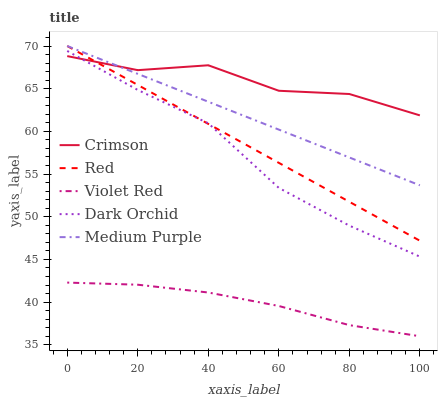Does Medium Purple have the minimum area under the curve?
Answer yes or no. No. Does Medium Purple have the maximum area under the curve?
Answer yes or no. No. Is Medium Purple the smoothest?
Answer yes or no. No. Is Medium Purple the roughest?
Answer yes or no. No. Does Medium Purple have the lowest value?
Answer yes or no. No. Does Violet Red have the highest value?
Answer yes or no. No. Is Dark Orchid less than Medium Purple?
Answer yes or no. Yes. Is Crimson greater than Violet Red?
Answer yes or no. Yes. Does Dark Orchid intersect Medium Purple?
Answer yes or no. No. 